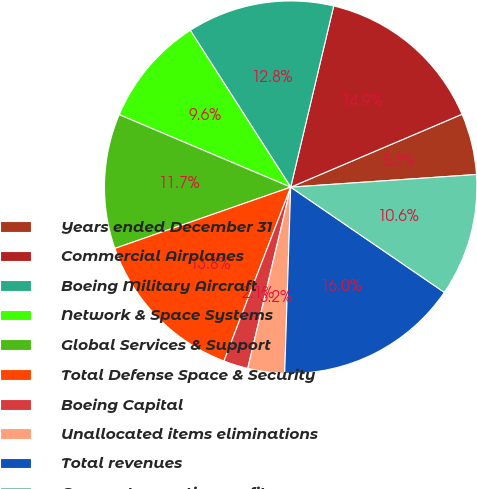Convert chart to OTSL. <chart><loc_0><loc_0><loc_500><loc_500><pie_chart><fcel>Years ended December 31<fcel>Commercial Airplanes<fcel>Boeing Military Aircraft<fcel>Network & Space Systems<fcel>Global Services & Support<fcel>Total Defense Space & Security<fcel>Boeing Capital<fcel>Unallocated items eliminations<fcel>Total revenues<fcel>Segment operating profit<nl><fcel>5.32%<fcel>14.89%<fcel>12.77%<fcel>9.57%<fcel>11.7%<fcel>13.83%<fcel>2.13%<fcel>3.19%<fcel>15.96%<fcel>10.64%<nl></chart> 